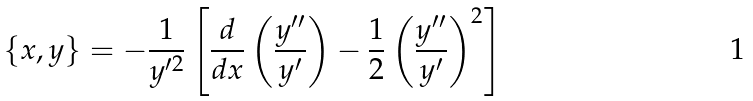Convert formula to latex. <formula><loc_0><loc_0><loc_500><loc_500>\{ x , y \} = - \frac { 1 } { y ^ { \prime 2 } } \left [ \frac { d } { d x } \left ( \frac { y ^ { \prime \prime } } { y ^ { \prime } } \right ) - \frac { 1 } { 2 } \left ( \frac { y ^ { \prime \prime } } { y ^ { \prime } } \right ) ^ { 2 } \right ]</formula> 